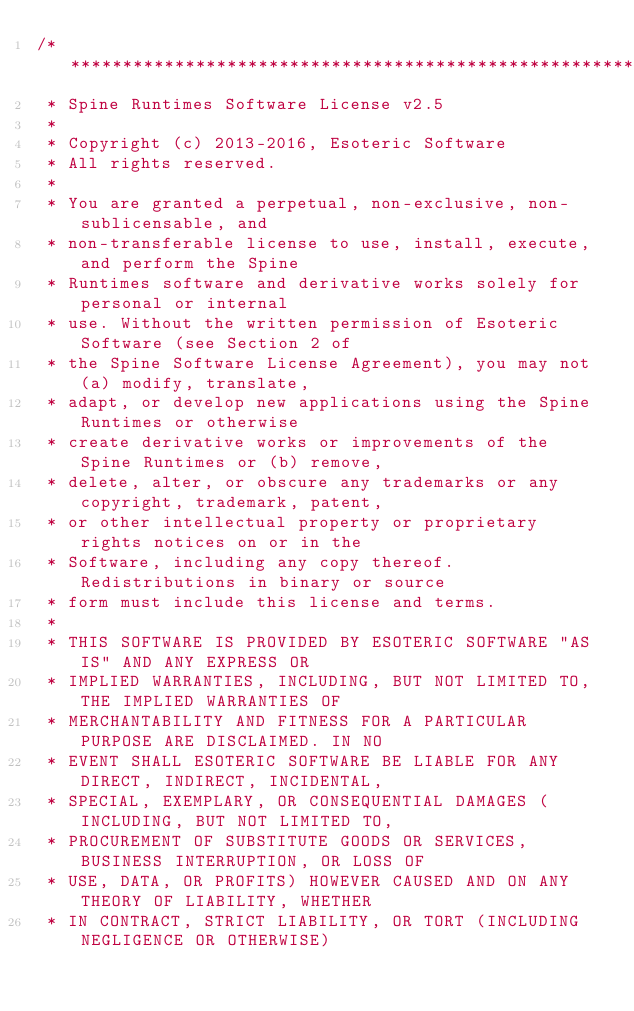<code> <loc_0><loc_0><loc_500><loc_500><_C_>/******************************************************************************
 * Spine Runtimes Software License v2.5
 * 
 * Copyright (c) 2013-2016, Esoteric Software
 * All rights reserved.
 * 
 * You are granted a perpetual, non-exclusive, non-sublicensable, and
 * non-transferable license to use, install, execute, and perform the Spine
 * Runtimes software and derivative works solely for personal or internal
 * use. Without the written permission of Esoteric Software (see Section 2 of
 * the Spine Software License Agreement), you may not (a) modify, translate,
 * adapt, or develop new applications using the Spine Runtimes or otherwise
 * create derivative works or improvements of the Spine Runtimes or (b) remove,
 * delete, alter, or obscure any trademarks or any copyright, trademark, patent,
 * or other intellectual property or proprietary rights notices on or in the
 * Software, including any copy thereof. Redistributions in binary or source
 * form must include this license and terms.
 * 
 * THIS SOFTWARE IS PROVIDED BY ESOTERIC SOFTWARE "AS IS" AND ANY EXPRESS OR
 * IMPLIED WARRANTIES, INCLUDING, BUT NOT LIMITED TO, THE IMPLIED WARRANTIES OF
 * MERCHANTABILITY AND FITNESS FOR A PARTICULAR PURPOSE ARE DISCLAIMED. IN NO
 * EVENT SHALL ESOTERIC SOFTWARE BE LIABLE FOR ANY DIRECT, INDIRECT, INCIDENTAL,
 * SPECIAL, EXEMPLARY, OR CONSEQUENTIAL DAMAGES (INCLUDING, BUT NOT LIMITED TO,
 * PROCUREMENT OF SUBSTITUTE GOODS OR SERVICES, BUSINESS INTERRUPTION, OR LOSS OF
 * USE, DATA, OR PROFITS) HOWEVER CAUSED AND ON ANY THEORY OF LIABILITY, WHETHER
 * IN CONTRACT, STRICT LIABILITY, OR TORT (INCLUDING NEGLIGENCE OR OTHERWISE)</code> 